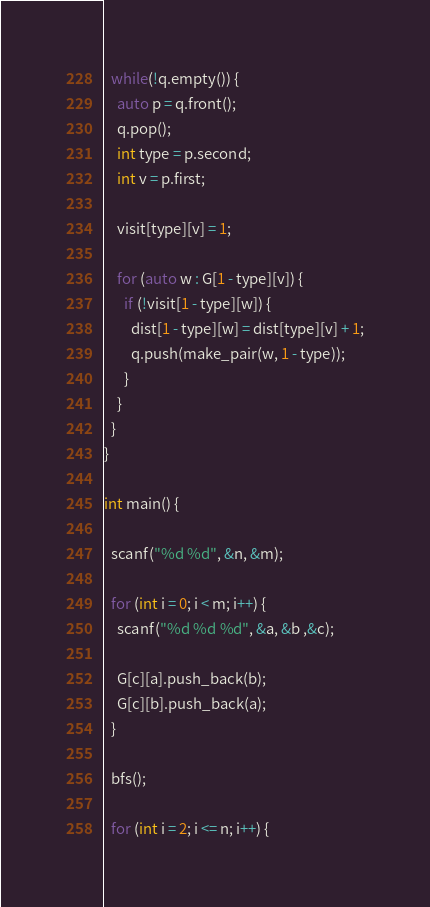Convert code to text. <code><loc_0><loc_0><loc_500><loc_500><_C++_>  while(!q.empty()) {
    auto p = q.front();
    q.pop();
    int type = p.second;
    int v = p.first;

    visit[type][v] = 1;

    for (auto w : G[1 - type][v]) {
      if (!visit[1 - type][w]) {
        dist[1 - type][w] = dist[type][v] + 1;
        q.push(make_pair(w, 1 - type));
      }
    }
  }
}

int main() {

  scanf("%d %d", &n, &m);

  for (int i = 0; i < m; i++) {
    scanf("%d %d %d", &a, &b ,&c);

    G[c][a].push_back(b);
    G[c][b].push_back(a);
  }

  bfs();

  for (int i = 2; i <= n; i++) {</code> 